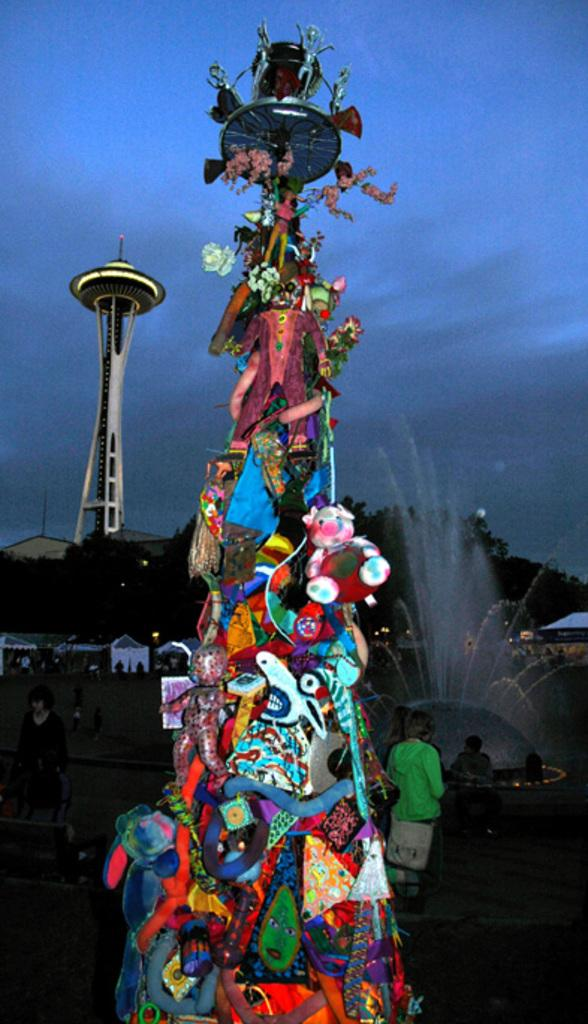What objects can be seen in the image? There are toys in the image. Are there any people present in the image? Yes, there are people in the image. What natural element is visible in the image? There is water visible in the image. What can be seen in the background of the image? There are trees, houses, and a tower in the background of the image. What type of behavior is exhibited by the trees in the image? There are no trees exhibiting behavior in the image, as trees are inanimate objects. What time of day is depicted in the image, based on the hour? The provided facts do not mention the time of day or any specific hour, so it cannot be determined from the image. 